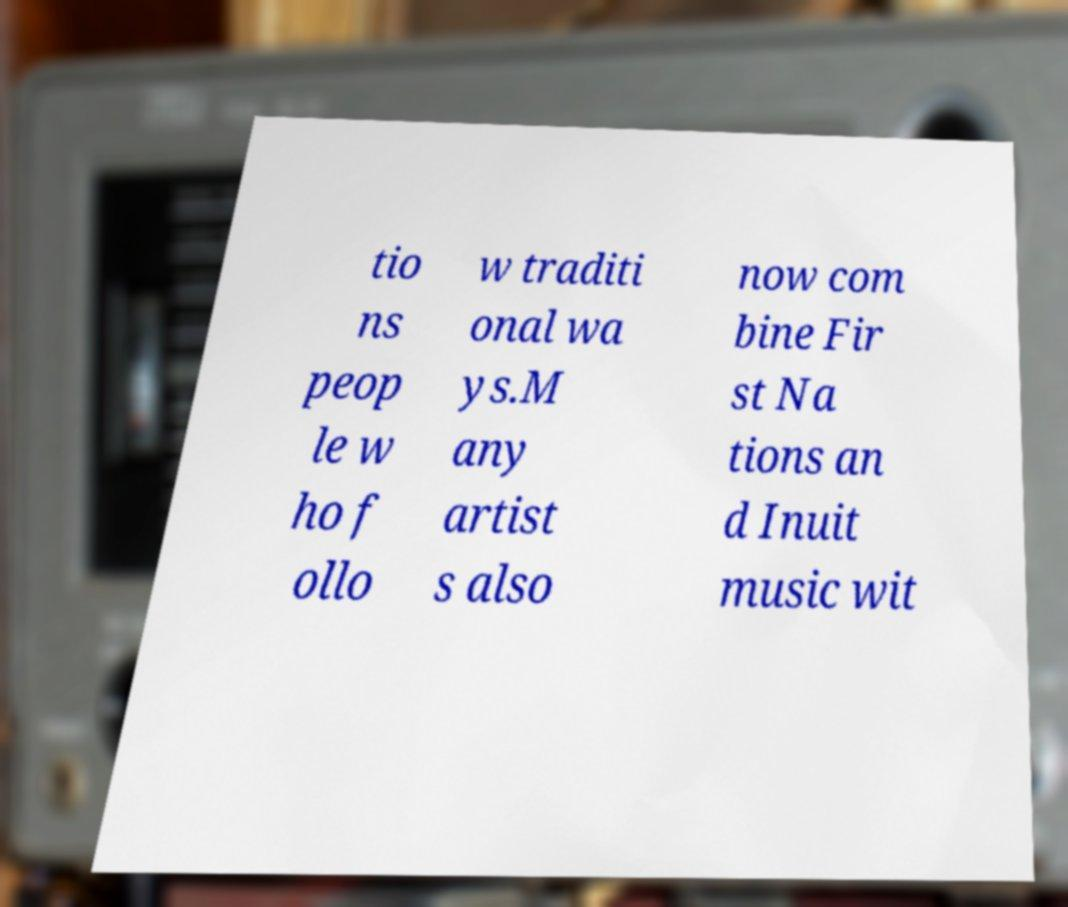Please identify and transcribe the text found in this image. tio ns peop le w ho f ollo w traditi onal wa ys.M any artist s also now com bine Fir st Na tions an d Inuit music wit 